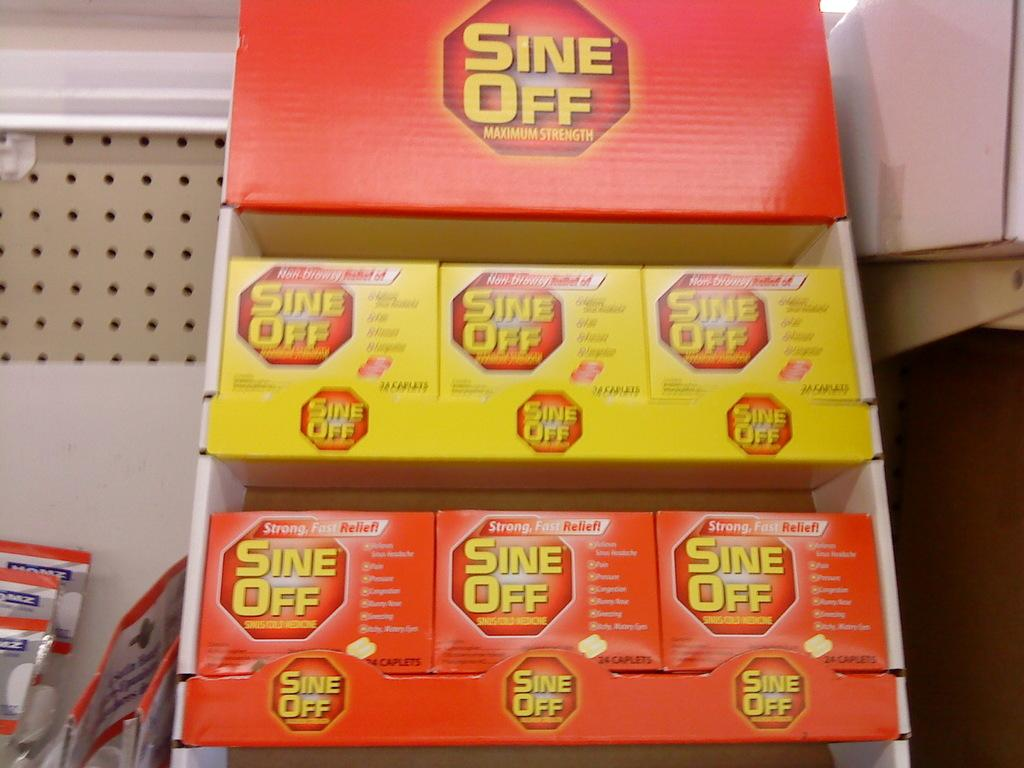Provide a one-sentence caption for the provided image. A container of Sine-Off Maximum Strength consists of multiple smaller packages. 